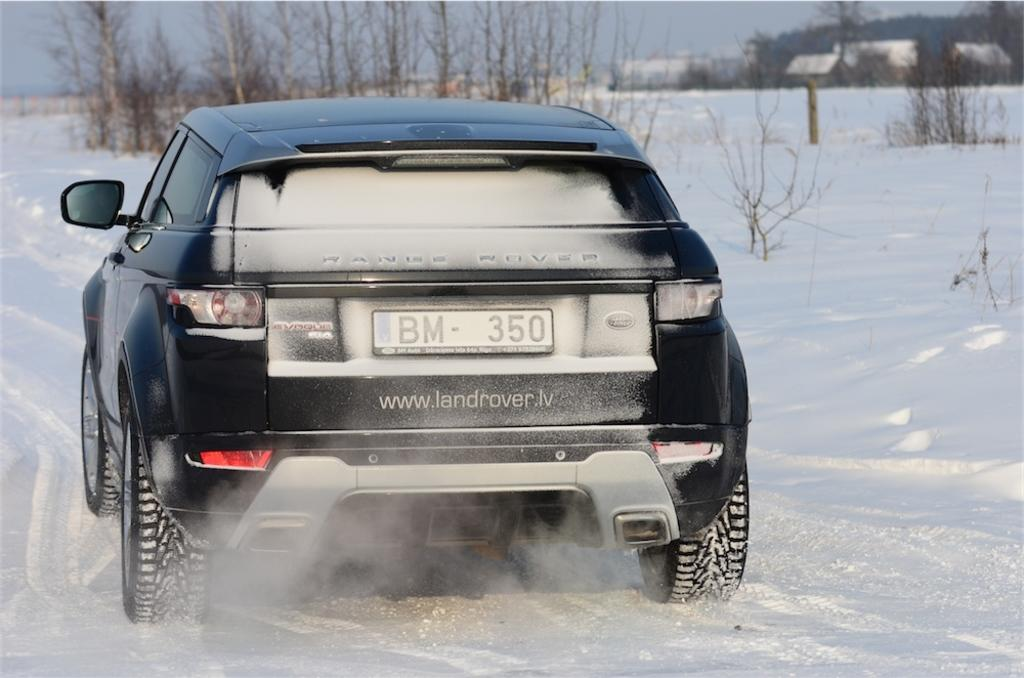<image>
Write a terse but informative summary of the picture. A black Land Rover with a tag that reads BM-350. 